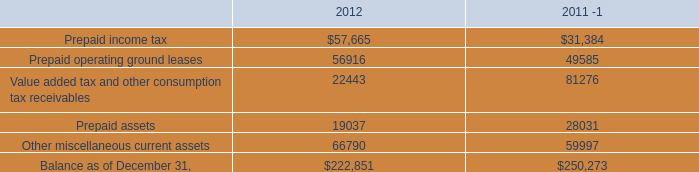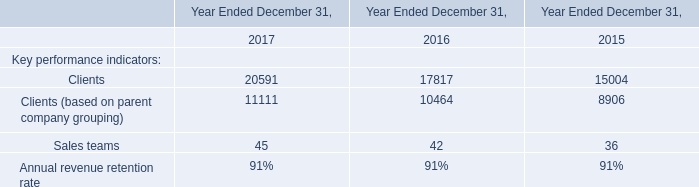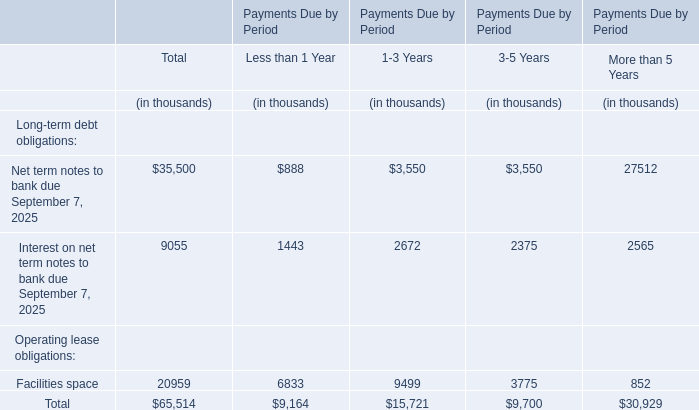What is the 50% of the value of the Total Long-term debt obligations? (in thousand) 
Computations: (0.5 * (35500 + 9055))
Answer: 22277.5. 